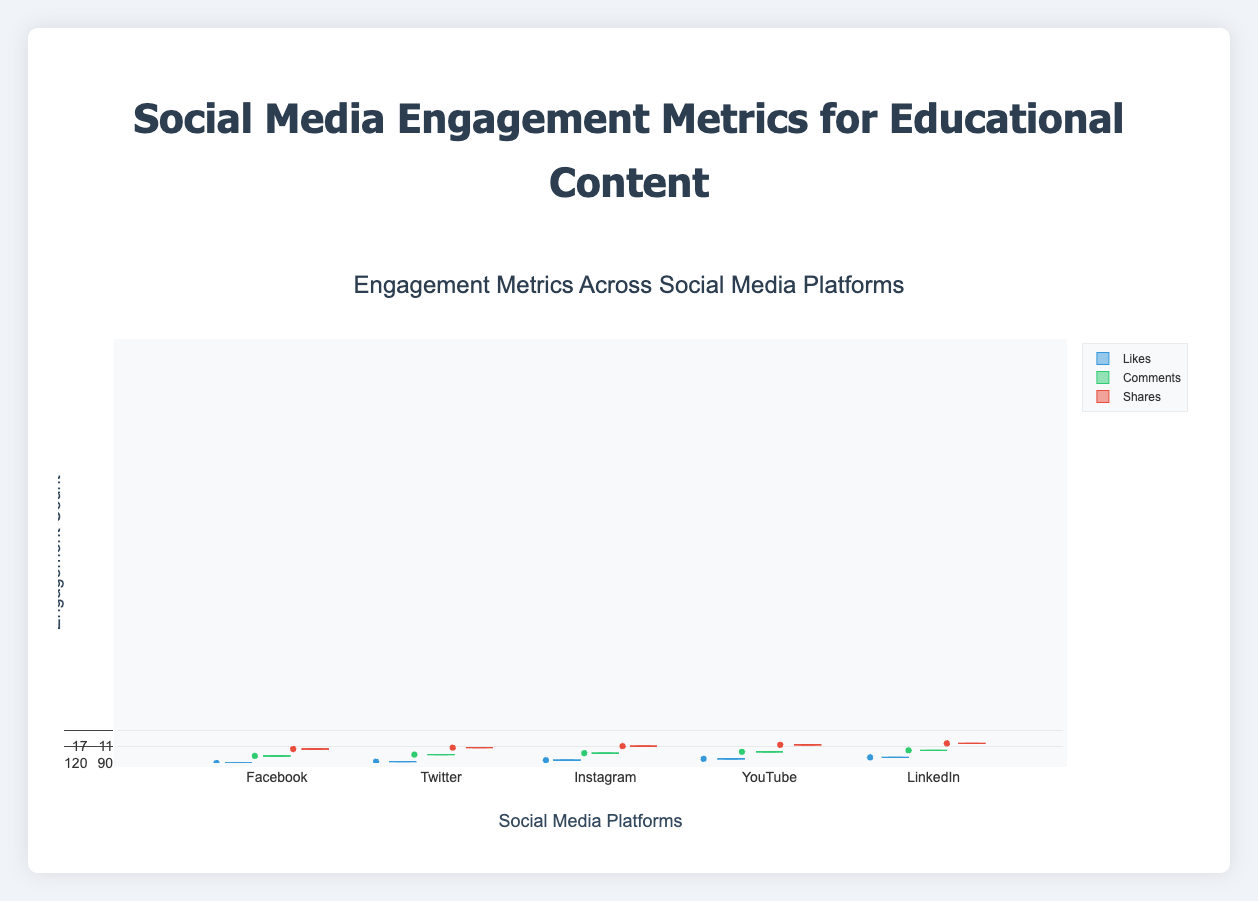Which social media platform has the highest median number of likes? Look at the boxes within the "Likes" group for each platform. The median is indicated by the line inside each box. The box for YouTube is higher than the others.
Answer: YouTube What is the range of the likes on Instagram? The range is the difference between the maximum and minimum values. On the box plot for Instagram's likes, the whiskers show the maximum and minimum. The minimum is 190, and the maximum is 230. The range is 230 - 190.
Answer: 40 Which platform has the greatest variability in comments? Variability can be observed by looking at the spread of the boxes and whiskers. The box and whiskers for YouTube's comments are wider compared to other platforms.
Answer: YouTube On which platform are shares most evenly distributed? Look for platforms where the box for shares has the smallest interquartile range (IQR) and shorter whiskers. LinkedIn shows the smallest box and whiskers, indicating the most even distribution.
Answer: LinkedIn What is the median number of comments on Facebook? The line inside the box for Facebook's comments indicates the median. The position of the line suggests the median value is approximately 28.
Answer: 28 Which platform has the least median number of likes? Compare the median lines within the "Likes" group for each platform. The lowest median line appears in LinkedIn's box plot.
Answer: LinkedIn How does the median number of shares on YouTube compare to Twitter? Compare the lines inside the boxes for shares on both platforms. YouTube's median is around 38, and Twitter's median is around 12.
Answer: Higher on YouTube What is the interquartile range (IQR) of likes on LinkedIn? The IQR is the range between the first quartile (Q1) and the third quartile (Q3). For LinkedIn, Q1 is 78, and Q3 is 90. The IQR is 90 - 78.
Answer: 12 